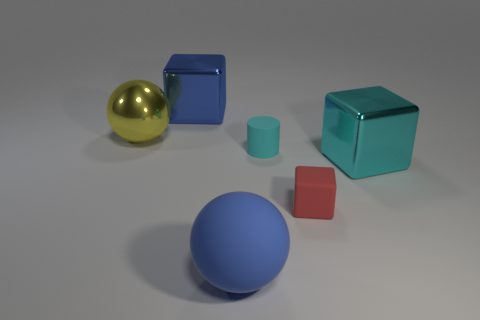Subtract all red rubber blocks. How many blocks are left? 2 Add 4 big yellow metallic things. How many objects exist? 10 Subtract all cyan blocks. How many blocks are left? 2 Subtract all green spheres. How many blue cubes are left? 1 Subtract 0 green cubes. How many objects are left? 6 Subtract all spheres. How many objects are left? 4 Subtract all cyan blocks. Subtract all yellow cylinders. How many blocks are left? 2 Subtract all tiny yellow metal cylinders. Subtract all metallic balls. How many objects are left? 5 Add 2 rubber cylinders. How many rubber cylinders are left? 3 Add 4 tiny yellow balls. How many tiny yellow balls exist? 4 